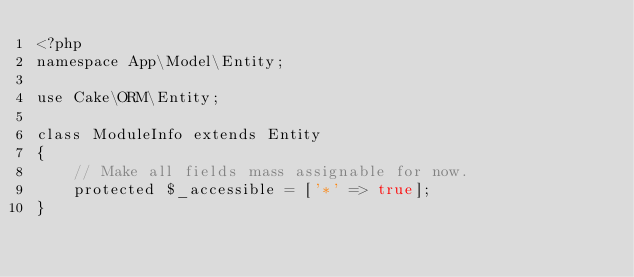Convert code to text. <code><loc_0><loc_0><loc_500><loc_500><_PHP_><?php
namespace App\Model\Entity;

use Cake\ORM\Entity;

class ModuleInfo extends Entity
{
    // Make all fields mass assignable for now.
    protected $_accessible = ['*' => true];
}</code> 